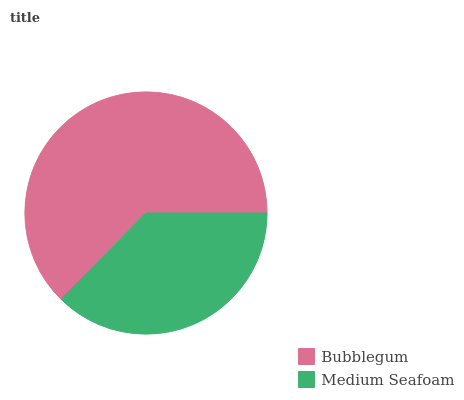Is Medium Seafoam the minimum?
Answer yes or no. Yes. Is Bubblegum the maximum?
Answer yes or no. Yes. Is Medium Seafoam the maximum?
Answer yes or no. No. Is Bubblegum greater than Medium Seafoam?
Answer yes or no. Yes. Is Medium Seafoam less than Bubblegum?
Answer yes or no. Yes. Is Medium Seafoam greater than Bubblegum?
Answer yes or no. No. Is Bubblegum less than Medium Seafoam?
Answer yes or no. No. Is Bubblegum the high median?
Answer yes or no. Yes. Is Medium Seafoam the low median?
Answer yes or no. Yes. Is Medium Seafoam the high median?
Answer yes or no. No. Is Bubblegum the low median?
Answer yes or no. No. 